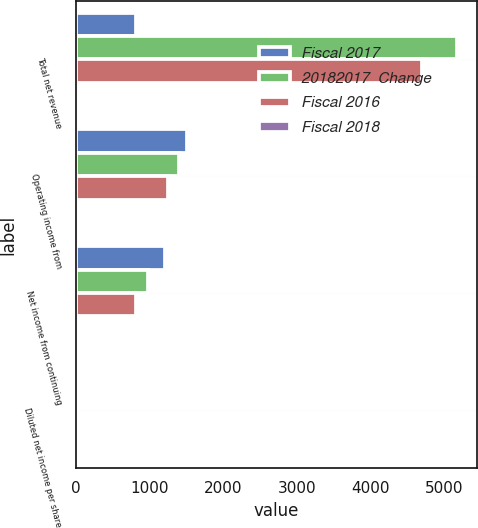Convert chart. <chart><loc_0><loc_0><loc_500><loc_500><stacked_bar_chart><ecel><fcel>Total net revenue<fcel>Operating income from<fcel>Net income from continuing<fcel>Diluted net income per share<nl><fcel>Fiscal 2017<fcel>806<fcel>1497<fcel>1211<fcel>4.64<nl><fcel>20182017  Change<fcel>5177<fcel>1395<fcel>971<fcel>3.72<nl><fcel>Fiscal 2016<fcel>4694<fcel>1242<fcel>806<fcel>3.04<nl><fcel>Fiscal 2018<fcel>15<fcel>7<fcel>25<fcel>25<nl></chart> 